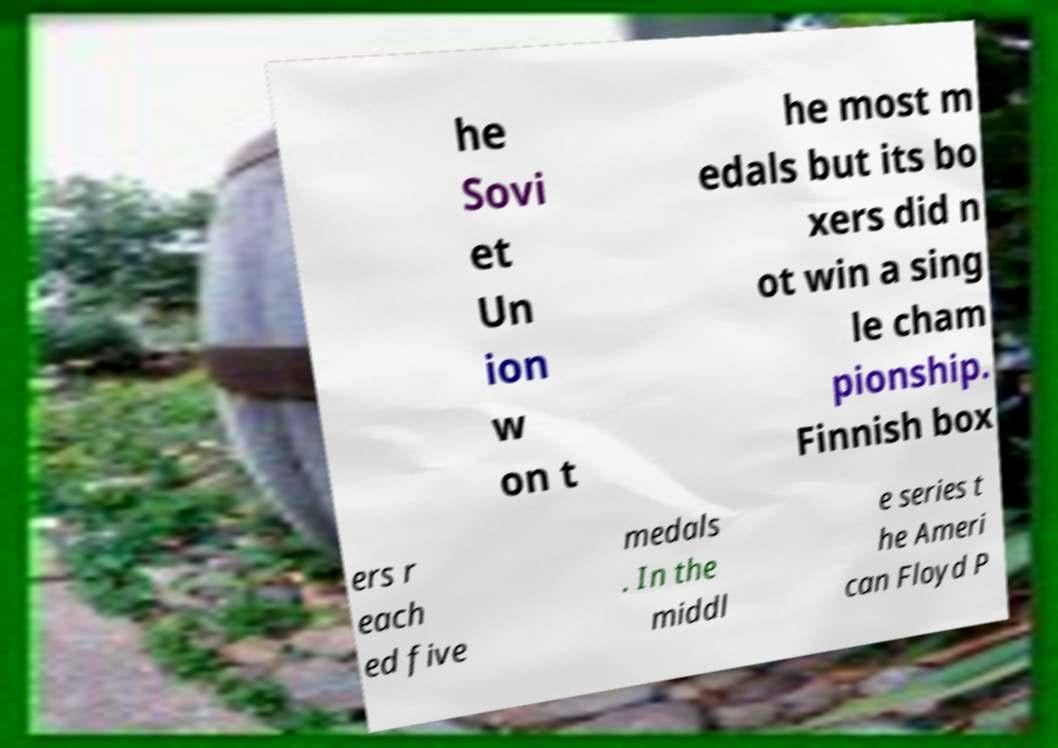Can you accurately transcribe the text from the provided image for me? he Sovi et Un ion w on t he most m edals but its bo xers did n ot win a sing le cham pionship. Finnish box ers r each ed five medals . In the middl e series t he Ameri can Floyd P 